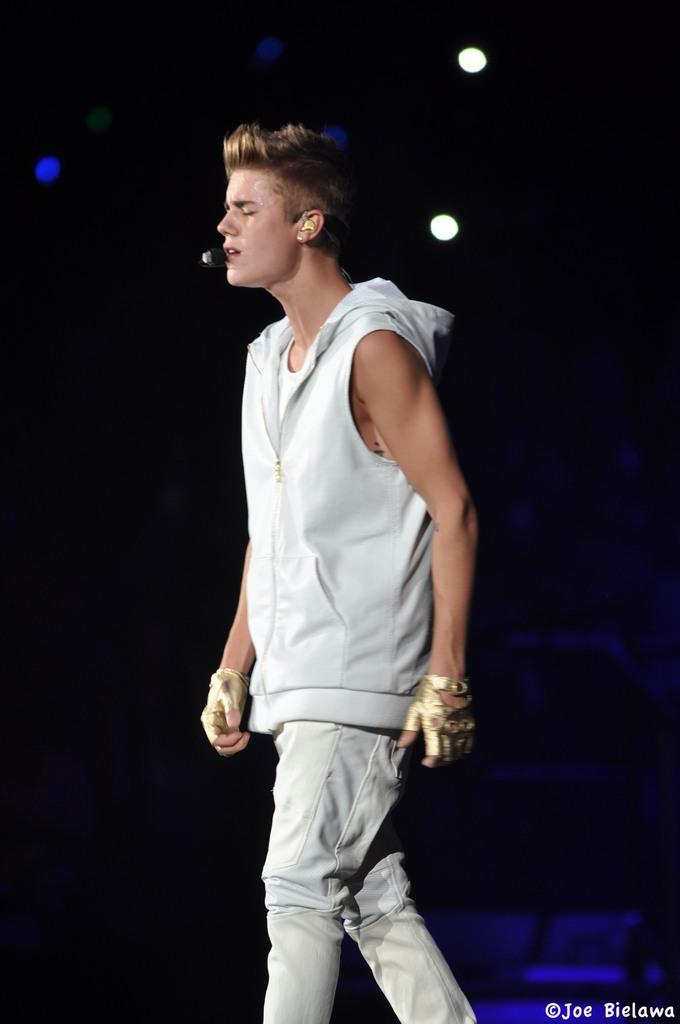What is the main subject of the image? There is a person standing in the center of the image. What is the person wearing? The person is wearing a microphone. What can be seen in the background of the image? There are lights in the background of the image. What is visible at the bottom of the image? The floor is visible at the bottom of the image. What type of food is the goose eating in the image? There is no goose or food present in the image. 